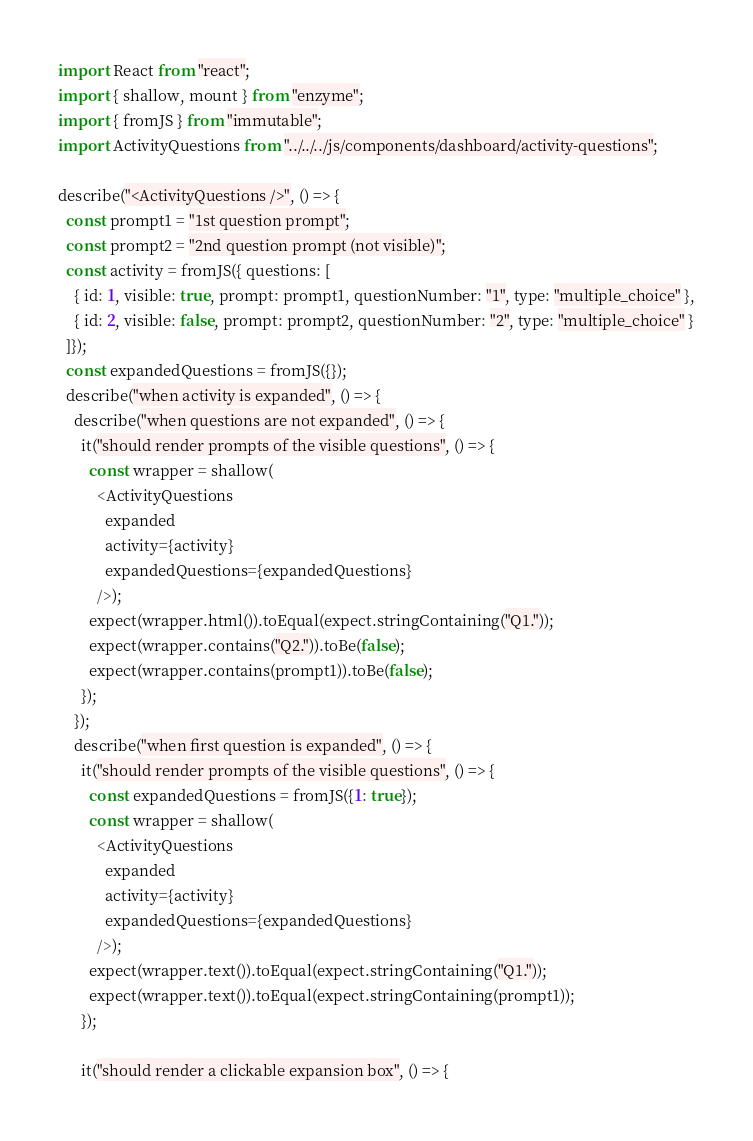<code> <loc_0><loc_0><loc_500><loc_500><_JavaScript_>import React from "react";
import { shallow, mount } from "enzyme";
import { fromJS } from "immutable";
import ActivityQuestions from "../../../js/components/dashboard/activity-questions";

describe("<ActivityQuestions />", () => {
  const prompt1 = "1st question prompt";
  const prompt2 = "2nd question prompt (not visible)";
  const activity = fromJS({ questions: [
    { id: 1, visible: true, prompt: prompt1, questionNumber: "1", type: "multiple_choice" },
    { id: 2, visible: false, prompt: prompt2, questionNumber: "2", type: "multiple_choice" }
  ]});
  const expandedQuestions = fromJS({});
  describe("when activity is expanded", () => {
    describe("when questions are not expanded", () => {
      it("should render prompts of the visible questions", () => {
        const wrapper = shallow(
          <ActivityQuestions
            expanded
            activity={activity}
            expandedQuestions={expandedQuestions}
          />);
        expect(wrapper.html()).toEqual(expect.stringContaining("Q1."));
        expect(wrapper.contains("Q2.")).toBe(false);
        expect(wrapper.contains(prompt1)).toBe(false);
      });
    });
    describe("when first question is expanded", () => {
      it("should render prompts of the visible questions", () => {
        const expandedQuestions = fromJS({1: true});
        const wrapper = shallow(
          <ActivityQuestions
            expanded
            activity={activity}
            expandedQuestions={expandedQuestions}
          />);
        expect(wrapper.text()).toEqual(expect.stringContaining("Q1."));
        expect(wrapper.text()).toEqual(expect.stringContaining(prompt1));
      });

      it("should render a clickable expansion box", () => {</code> 